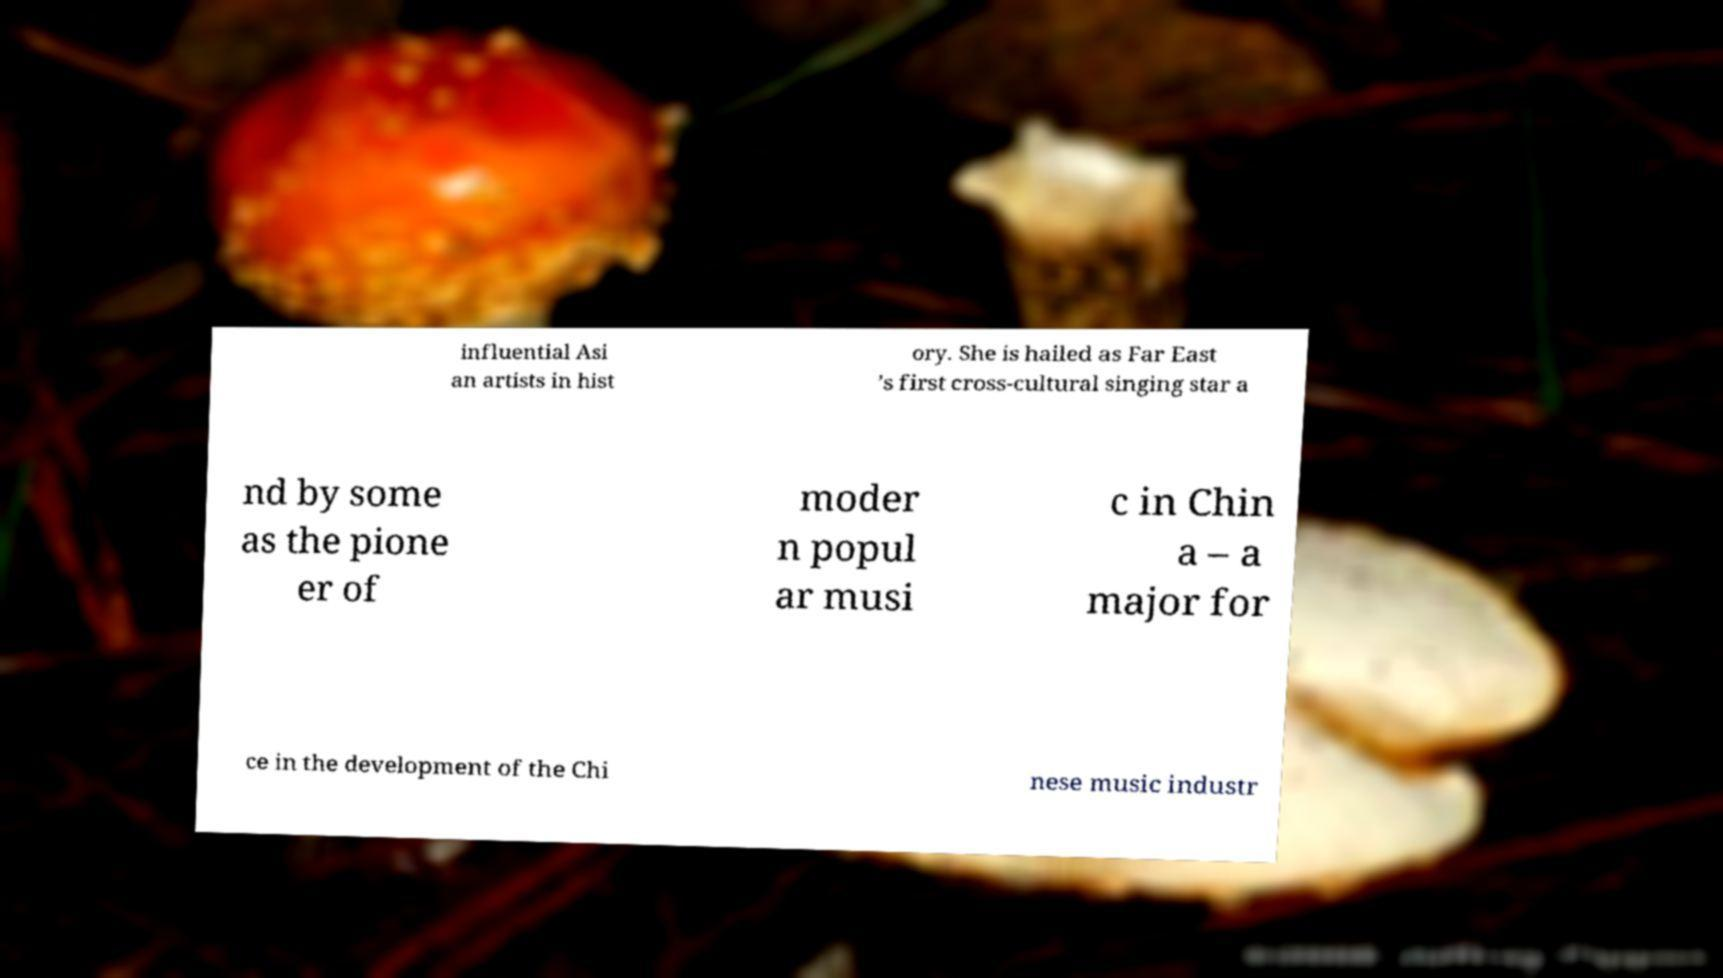Please identify and transcribe the text found in this image. influential Asi an artists in hist ory. She is hailed as Far East ’s first cross-cultural singing star a nd by some as the pione er of moder n popul ar musi c in Chin a – a major for ce in the development of the Chi nese music industr 